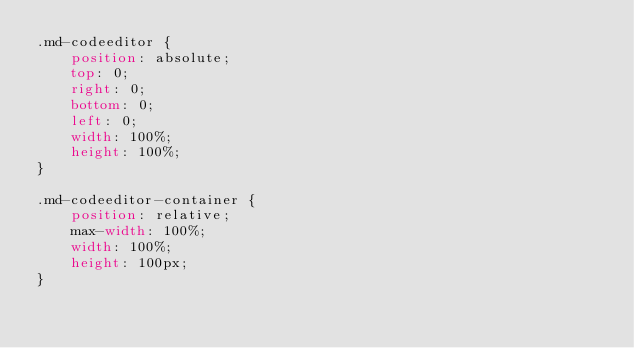<code> <loc_0><loc_0><loc_500><loc_500><_CSS_>.md-codeeditor {
    position: absolute;
    top: 0;
    right: 0;
    bottom: 0;
    left: 0;
    width: 100%;
    height: 100%;
}

.md-codeeditor-container {
    position: relative;
    max-width: 100%;
    width: 100%;
    height: 100px;
}
</code> 